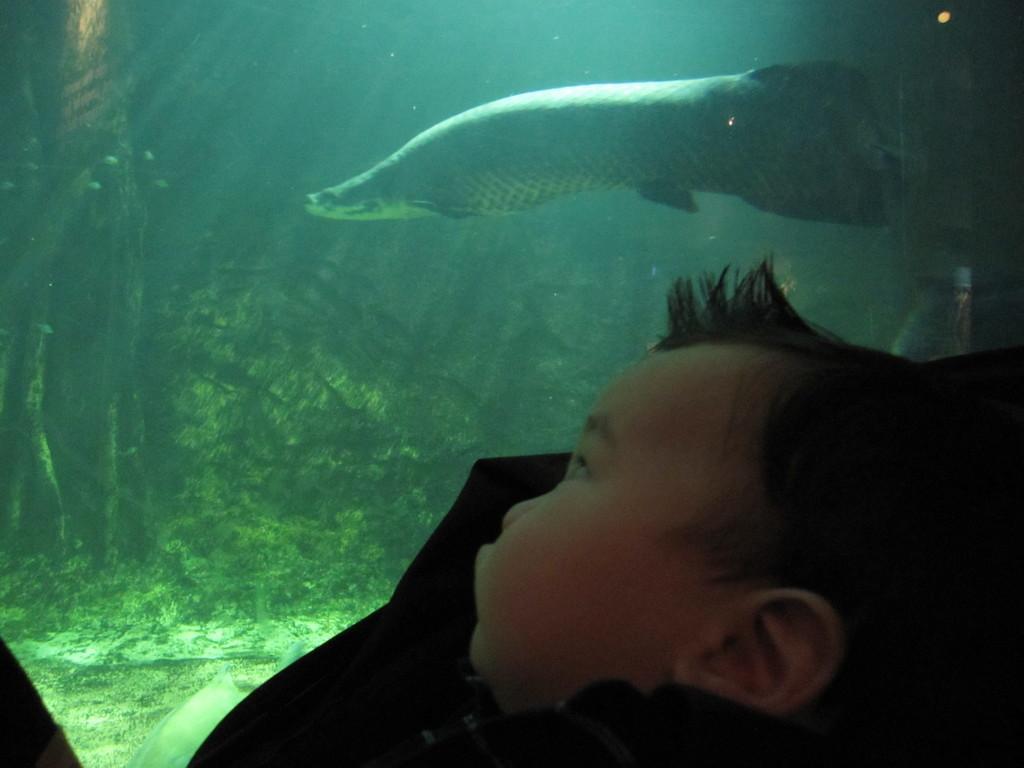Describe this image in one or two sentences. In this picture we can observe a baby. In the background we can observe an aquarium in which there is a fish swimming. We can observe some plants in the water. 